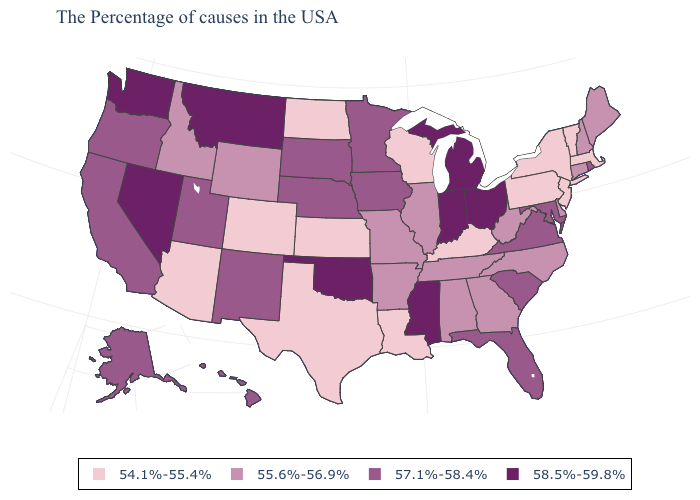Does New Jersey have the lowest value in the USA?
Concise answer only. Yes. How many symbols are there in the legend?
Write a very short answer. 4. What is the value of Virginia?
Keep it brief. 57.1%-58.4%. Does Rhode Island have the highest value in the Northeast?
Write a very short answer. Yes. Among the states that border Nebraska , which have the highest value?
Answer briefly. Iowa, South Dakota. Which states have the lowest value in the West?
Write a very short answer. Colorado, Arizona. What is the value of Hawaii?
Write a very short answer. 57.1%-58.4%. Which states have the lowest value in the USA?
Short answer required. Massachusetts, Vermont, New York, New Jersey, Pennsylvania, Kentucky, Wisconsin, Louisiana, Kansas, Texas, North Dakota, Colorado, Arizona. Name the states that have a value in the range 54.1%-55.4%?
Concise answer only. Massachusetts, Vermont, New York, New Jersey, Pennsylvania, Kentucky, Wisconsin, Louisiana, Kansas, Texas, North Dakota, Colorado, Arizona. Name the states that have a value in the range 58.5%-59.8%?
Be succinct. Ohio, Michigan, Indiana, Mississippi, Oklahoma, Montana, Nevada, Washington. Does California have the same value as Pennsylvania?
Give a very brief answer. No. Name the states that have a value in the range 57.1%-58.4%?
Give a very brief answer. Rhode Island, Maryland, Virginia, South Carolina, Florida, Minnesota, Iowa, Nebraska, South Dakota, New Mexico, Utah, California, Oregon, Alaska, Hawaii. Name the states that have a value in the range 55.6%-56.9%?
Be succinct. Maine, New Hampshire, Connecticut, Delaware, North Carolina, West Virginia, Georgia, Alabama, Tennessee, Illinois, Missouri, Arkansas, Wyoming, Idaho. How many symbols are there in the legend?
Concise answer only. 4. What is the lowest value in the West?
Be succinct. 54.1%-55.4%. 